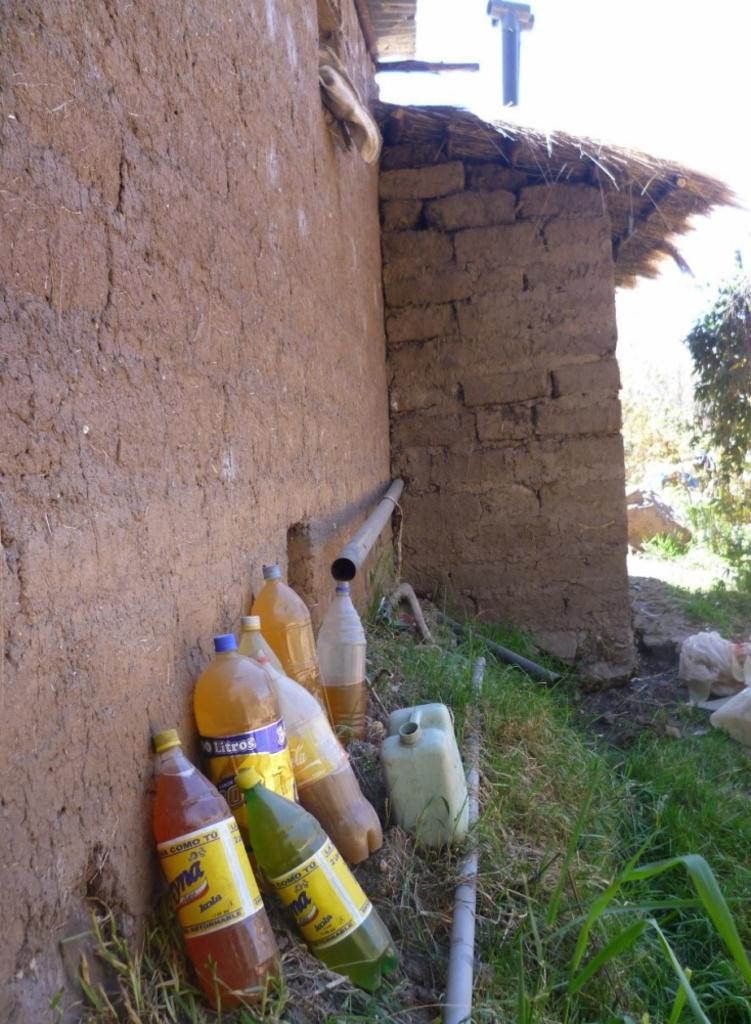Could you give a brief overview of what you see in this image? This picture is consists of bottles which are kept at a side and there is a hut at the left side of the image and there are some trees around the area of the image and there are iron rods at the center of the image. 